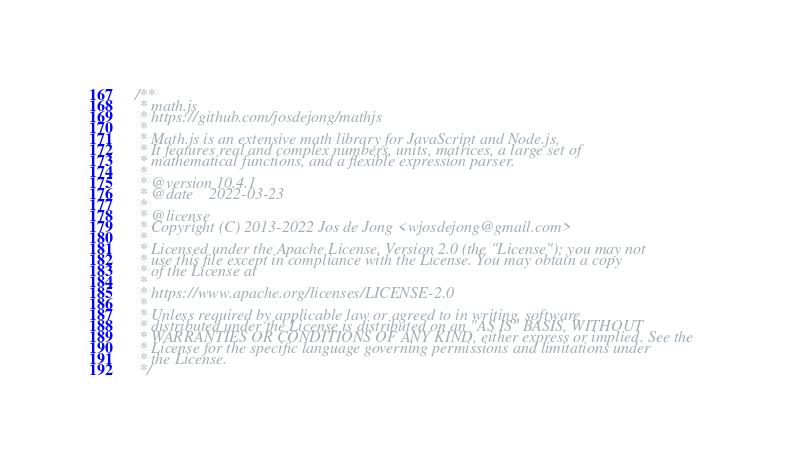Convert code to text. <code><loc_0><loc_0><loc_500><loc_500><_JavaScript_>/**
 * math.js
 * https://github.com/josdejong/mathjs
 *
 * Math.js is an extensive math library for JavaScript and Node.js,
 * It features real and complex numbers, units, matrices, a large set of
 * mathematical functions, and a flexible expression parser.
 *
 * @version 10.4.1
 * @date    2022-03-23
 *
 * @license
 * Copyright (C) 2013-2022 Jos de Jong <wjosdejong@gmail.com>
 *
 * Licensed under the Apache License, Version 2.0 (the "License"); you may not
 * use this file except in compliance with the License. You may obtain a copy
 * of the License at
 *
 * https://www.apache.org/licenses/LICENSE-2.0
 *
 * Unless required by applicable law or agreed to in writing, software
 * distributed under the License is distributed on an "AS IS" BASIS, WITHOUT
 * WARRANTIES OR CONDITIONS OF ANY KIND, either express or implied. See the
 * License for the specific language governing permissions and limitations under
 * the License.
 */
</code> 